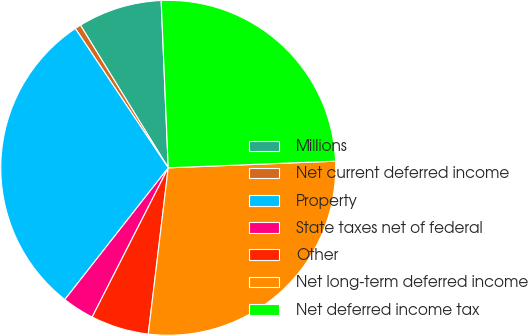Convert chart to OTSL. <chart><loc_0><loc_0><loc_500><loc_500><pie_chart><fcel>Millions<fcel>Net current deferred income<fcel>Property<fcel>State taxes net of federal<fcel>Other<fcel>Net long-term deferred income<fcel>Net deferred income tax<nl><fcel>8.11%<fcel>0.58%<fcel>30.05%<fcel>3.09%<fcel>5.6%<fcel>27.54%<fcel>25.04%<nl></chart> 